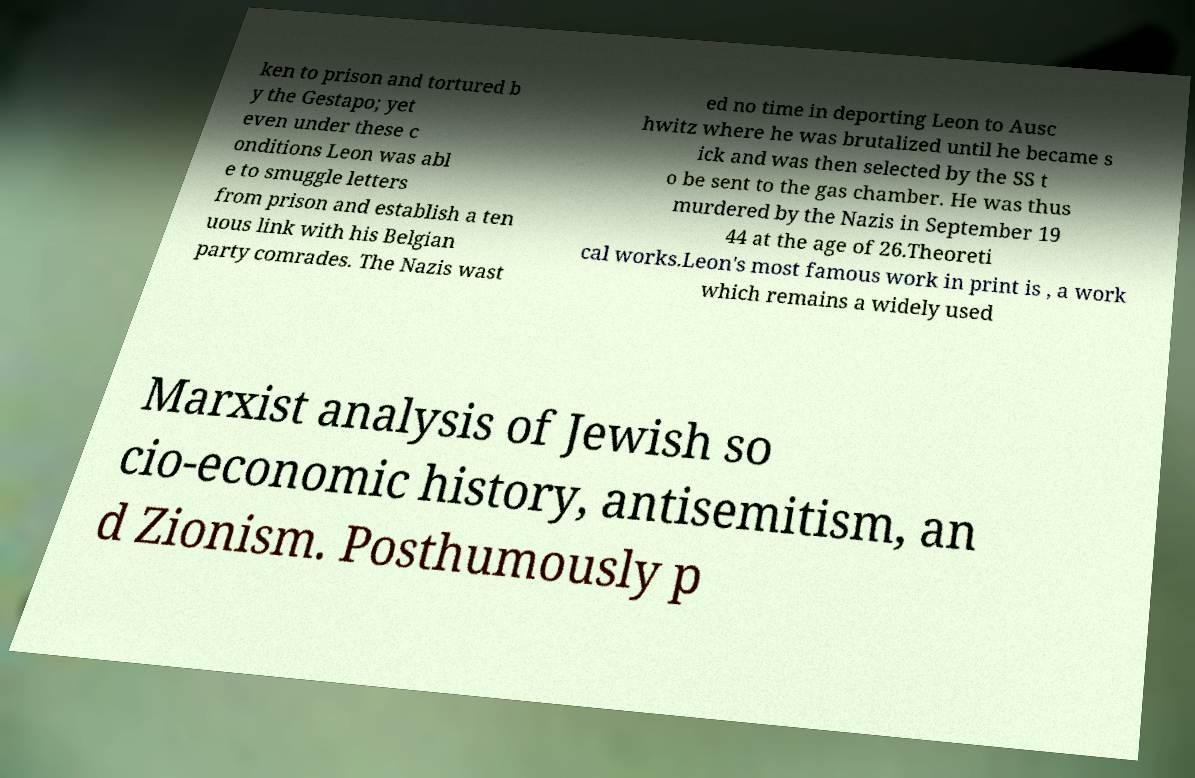Please identify and transcribe the text found in this image. ken to prison and tortured b y the Gestapo; yet even under these c onditions Leon was abl e to smuggle letters from prison and establish a ten uous link with his Belgian party comrades. The Nazis wast ed no time in deporting Leon to Ausc hwitz where he was brutalized until he became s ick and was then selected by the SS t o be sent to the gas chamber. He was thus murdered by the Nazis in September 19 44 at the age of 26.Theoreti cal works.Leon's most famous work in print is , a work which remains a widely used Marxist analysis of Jewish so cio-economic history, antisemitism, an d Zionism. Posthumously p 